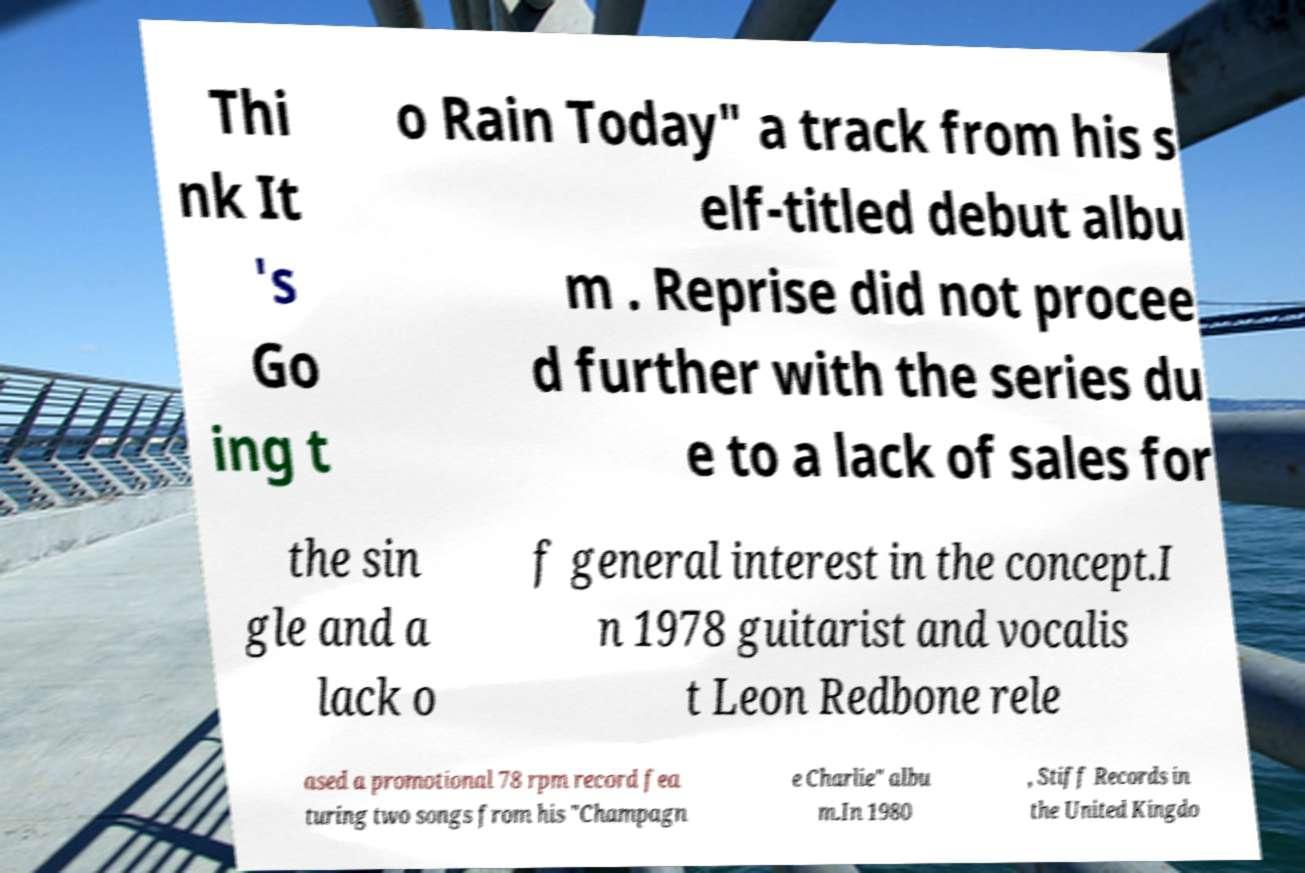For documentation purposes, I need the text within this image transcribed. Could you provide that? Thi nk It 's Go ing t o Rain Today" a track from his s elf-titled debut albu m . Reprise did not procee d further with the series du e to a lack of sales for the sin gle and a lack o f general interest in the concept.I n 1978 guitarist and vocalis t Leon Redbone rele ased a promotional 78 rpm record fea turing two songs from his "Champagn e Charlie" albu m.In 1980 , Stiff Records in the United Kingdo 